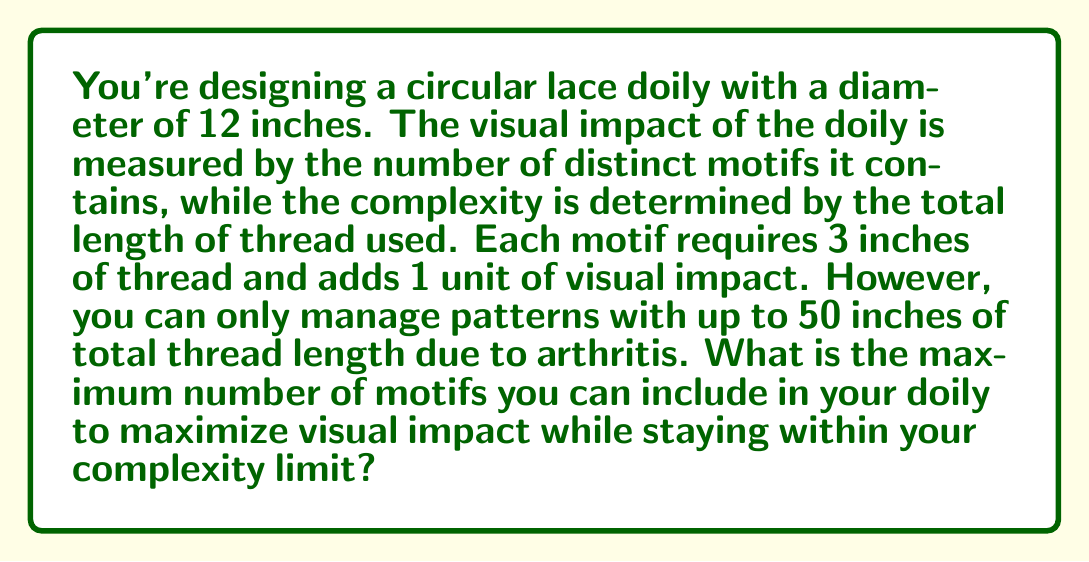Can you answer this question? Let's approach this step-by-step:

1) Let $x$ be the number of motifs in the doily.

2) Each motif requires 3 inches of thread, so the total length of thread used is $3x$ inches.

3) The complexity constraint can be expressed as:

   $$3x \leq 50$$

4) We want to maximize $x$, which represents both the number of motifs and the visual impact.

5) To find the maximum value of $x$, we solve the inequality:

   $$3x = 50$$
   $$x = \frac{50}{3} \approx 16.67$$

6) Since $x$ must be a whole number (we can't have a fraction of a motif), we round down to the nearest integer.

7) Therefore, the maximum number of motifs is 16.

8) We can verify: $16 * 3 = 48$ inches of thread, which is within the 50-inch limit.
Answer: The maximum number of motifs is 16. 